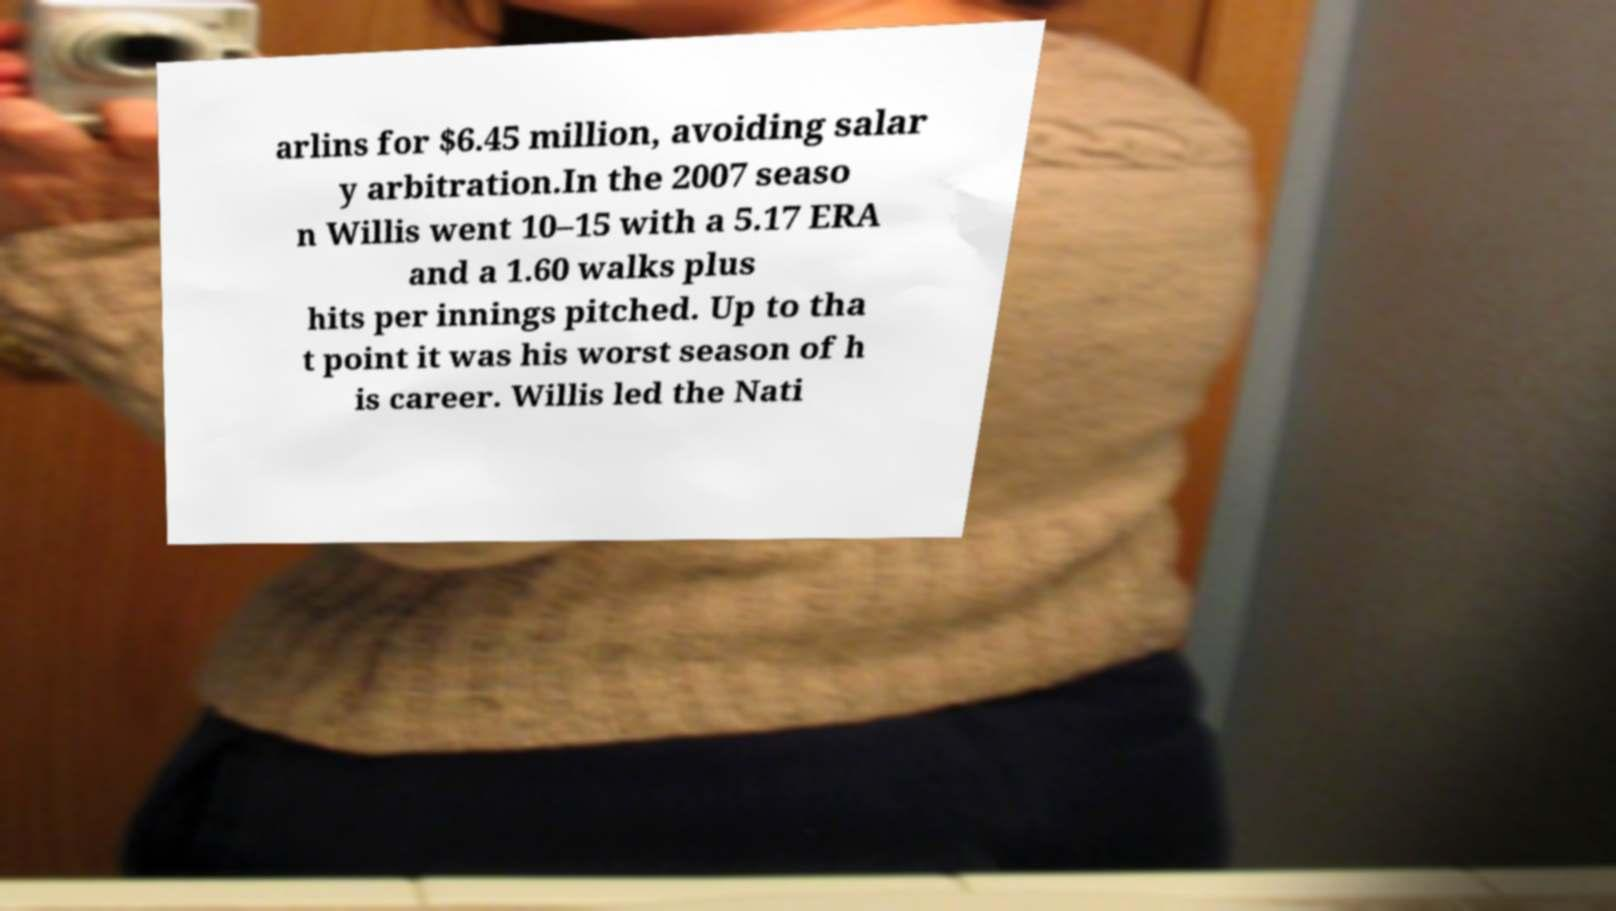For documentation purposes, I need the text within this image transcribed. Could you provide that? arlins for $6.45 million, avoiding salar y arbitration.In the 2007 seaso n Willis went 10–15 with a 5.17 ERA and a 1.60 walks plus hits per innings pitched. Up to tha t point it was his worst season of h is career. Willis led the Nati 